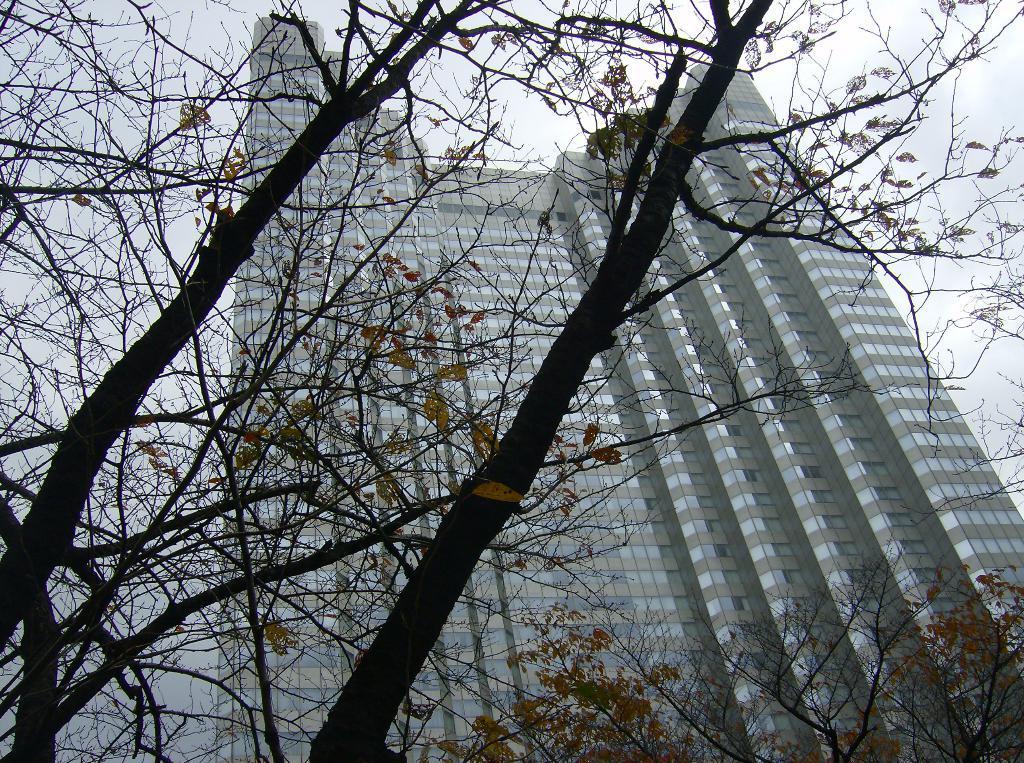Can you describe this image briefly? In this image we can see a building. There are many trees in the image. We can see the sky in the image. 